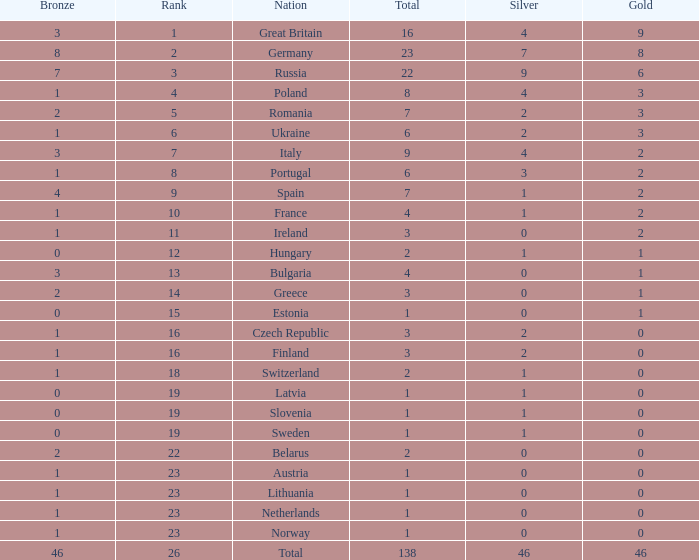What is the most bronze can be when silver is larger than 2, and the nation is germany, and gold is more than 8? None. 